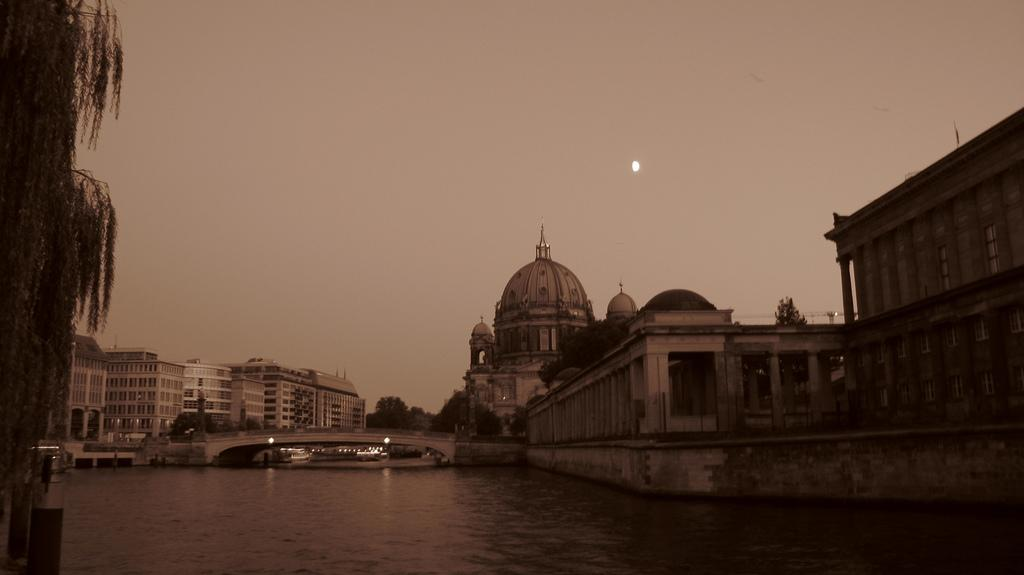What is present at the bottom of the image? There is water at the bottom of the image. What can be seen on the left side of the image? There is a tree on the left side of the image. What structures are visible in the background of the image? There are buildings, trees, and a bridge in the background of the image. What type of machinery can be seen in the background of the image? There is a crane in the background of the image. What celestial object is visible in the sky? There is a half moon visible in the sky. What type of basin is being used to prepare the meal in the image? There is no basin or meal preparation visible in the image. How does the brake system work on the crane in the image? There is no brake system present on the crane in the image; it is a static object in the background. 